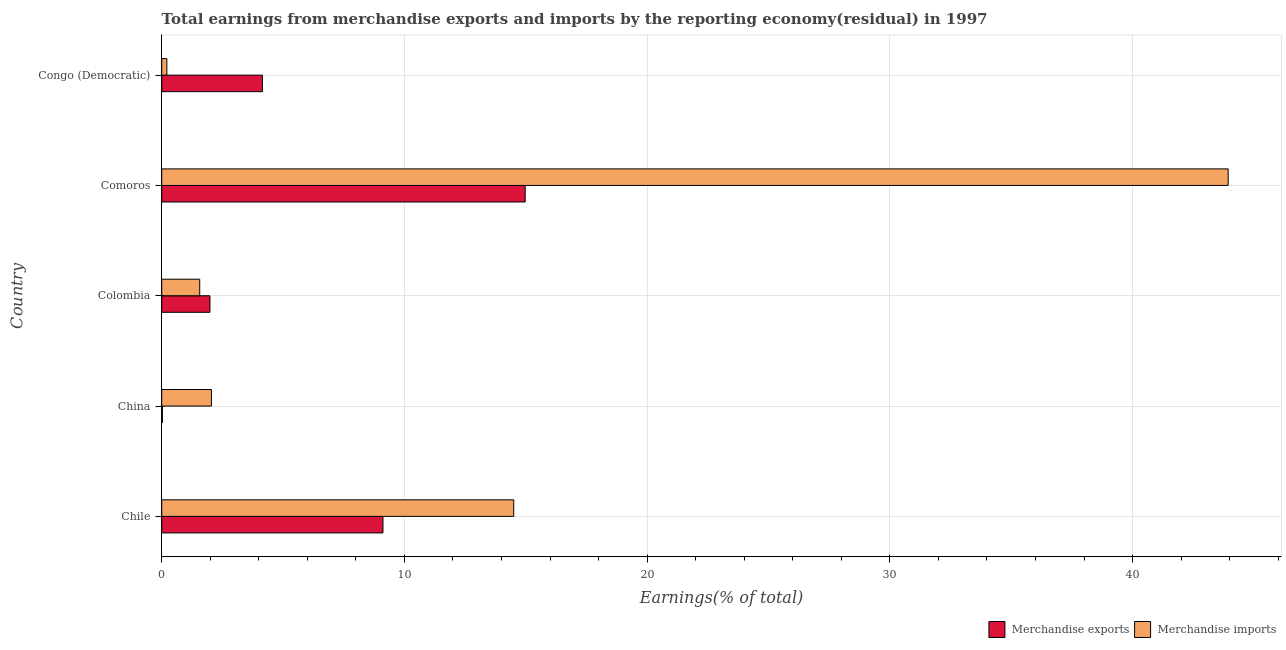How many groups of bars are there?
Your answer should be compact. 5. Are the number of bars per tick equal to the number of legend labels?
Provide a succinct answer. Yes. Are the number of bars on each tick of the Y-axis equal?
Your answer should be compact. Yes. How many bars are there on the 1st tick from the top?
Offer a terse response. 2. What is the earnings from merchandise imports in Chile?
Ensure brevity in your answer.  14.5. Across all countries, what is the maximum earnings from merchandise imports?
Your answer should be very brief. 43.94. Across all countries, what is the minimum earnings from merchandise exports?
Provide a short and direct response. 0.03. In which country was the earnings from merchandise imports maximum?
Make the answer very short. Comoros. What is the total earnings from merchandise exports in the graph?
Your answer should be compact. 30.26. What is the difference between the earnings from merchandise imports in China and that in Comoros?
Keep it short and to the point. -41.89. What is the difference between the earnings from merchandise exports in Colombia and the earnings from merchandise imports in Chile?
Offer a very short reply. -12.52. What is the average earnings from merchandise imports per country?
Give a very brief answer. 12.45. What is the difference between the earnings from merchandise imports and earnings from merchandise exports in Chile?
Offer a very short reply. 5.39. What is the ratio of the earnings from merchandise imports in Comoros to that in Congo (Democratic)?
Your response must be concise. 207.36. Is the earnings from merchandise imports in China less than that in Colombia?
Your answer should be very brief. No. Is the difference between the earnings from merchandise exports in China and Comoros greater than the difference between the earnings from merchandise imports in China and Comoros?
Provide a short and direct response. Yes. What is the difference between the highest and the second highest earnings from merchandise exports?
Provide a succinct answer. 5.86. What is the difference between the highest and the lowest earnings from merchandise imports?
Give a very brief answer. 43.73. In how many countries, is the earnings from merchandise imports greater than the average earnings from merchandise imports taken over all countries?
Offer a terse response. 2. Is the sum of the earnings from merchandise imports in Chile and Comoros greater than the maximum earnings from merchandise exports across all countries?
Provide a short and direct response. Yes. What does the 2nd bar from the top in China represents?
Keep it short and to the point. Merchandise exports. What does the 1st bar from the bottom in Colombia represents?
Offer a terse response. Merchandise exports. Are all the bars in the graph horizontal?
Your response must be concise. Yes. How many countries are there in the graph?
Give a very brief answer. 5. Does the graph contain any zero values?
Make the answer very short. No. Where does the legend appear in the graph?
Offer a very short reply. Bottom right. How many legend labels are there?
Make the answer very short. 2. How are the legend labels stacked?
Keep it short and to the point. Horizontal. What is the title of the graph?
Your answer should be very brief. Total earnings from merchandise exports and imports by the reporting economy(residual) in 1997. Does "Registered firms" appear as one of the legend labels in the graph?
Make the answer very short. No. What is the label or title of the X-axis?
Keep it short and to the point. Earnings(% of total). What is the label or title of the Y-axis?
Provide a succinct answer. Country. What is the Earnings(% of total) in Merchandise exports in Chile?
Offer a terse response. 9.12. What is the Earnings(% of total) in Merchandise imports in Chile?
Offer a very short reply. 14.5. What is the Earnings(% of total) in Merchandise exports in China?
Your response must be concise. 0.03. What is the Earnings(% of total) in Merchandise imports in China?
Offer a terse response. 2.05. What is the Earnings(% of total) of Merchandise exports in Colombia?
Your response must be concise. 1.99. What is the Earnings(% of total) in Merchandise imports in Colombia?
Offer a terse response. 1.57. What is the Earnings(% of total) of Merchandise exports in Comoros?
Make the answer very short. 14.98. What is the Earnings(% of total) in Merchandise imports in Comoros?
Ensure brevity in your answer.  43.94. What is the Earnings(% of total) in Merchandise exports in Congo (Democratic)?
Provide a succinct answer. 4.15. What is the Earnings(% of total) in Merchandise imports in Congo (Democratic)?
Offer a terse response. 0.21. Across all countries, what is the maximum Earnings(% of total) of Merchandise exports?
Give a very brief answer. 14.98. Across all countries, what is the maximum Earnings(% of total) in Merchandise imports?
Offer a very short reply. 43.94. Across all countries, what is the minimum Earnings(% of total) of Merchandise exports?
Ensure brevity in your answer.  0.03. Across all countries, what is the minimum Earnings(% of total) in Merchandise imports?
Offer a very short reply. 0.21. What is the total Earnings(% of total) in Merchandise exports in the graph?
Give a very brief answer. 30.26. What is the total Earnings(% of total) of Merchandise imports in the graph?
Give a very brief answer. 62.27. What is the difference between the Earnings(% of total) in Merchandise exports in Chile and that in China?
Offer a terse response. 9.09. What is the difference between the Earnings(% of total) of Merchandise imports in Chile and that in China?
Your response must be concise. 12.46. What is the difference between the Earnings(% of total) of Merchandise exports in Chile and that in Colombia?
Offer a very short reply. 7.13. What is the difference between the Earnings(% of total) of Merchandise imports in Chile and that in Colombia?
Your answer should be very brief. 12.94. What is the difference between the Earnings(% of total) of Merchandise exports in Chile and that in Comoros?
Your response must be concise. -5.86. What is the difference between the Earnings(% of total) in Merchandise imports in Chile and that in Comoros?
Provide a short and direct response. -29.44. What is the difference between the Earnings(% of total) of Merchandise exports in Chile and that in Congo (Democratic)?
Offer a very short reply. 4.97. What is the difference between the Earnings(% of total) in Merchandise imports in Chile and that in Congo (Democratic)?
Provide a succinct answer. 14.29. What is the difference between the Earnings(% of total) of Merchandise exports in China and that in Colombia?
Give a very brief answer. -1.96. What is the difference between the Earnings(% of total) in Merchandise imports in China and that in Colombia?
Make the answer very short. 0.48. What is the difference between the Earnings(% of total) of Merchandise exports in China and that in Comoros?
Make the answer very short. -14.95. What is the difference between the Earnings(% of total) in Merchandise imports in China and that in Comoros?
Keep it short and to the point. -41.89. What is the difference between the Earnings(% of total) of Merchandise exports in China and that in Congo (Democratic)?
Offer a very short reply. -4.12. What is the difference between the Earnings(% of total) in Merchandise imports in China and that in Congo (Democratic)?
Provide a short and direct response. 1.84. What is the difference between the Earnings(% of total) in Merchandise exports in Colombia and that in Comoros?
Your answer should be very brief. -12.99. What is the difference between the Earnings(% of total) in Merchandise imports in Colombia and that in Comoros?
Make the answer very short. -42.37. What is the difference between the Earnings(% of total) in Merchandise exports in Colombia and that in Congo (Democratic)?
Give a very brief answer. -2.16. What is the difference between the Earnings(% of total) of Merchandise imports in Colombia and that in Congo (Democratic)?
Offer a terse response. 1.35. What is the difference between the Earnings(% of total) of Merchandise exports in Comoros and that in Congo (Democratic)?
Provide a succinct answer. 10.83. What is the difference between the Earnings(% of total) of Merchandise imports in Comoros and that in Congo (Democratic)?
Keep it short and to the point. 43.73. What is the difference between the Earnings(% of total) of Merchandise exports in Chile and the Earnings(% of total) of Merchandise imports in China?
Ensure brevity in your answer.  7.07. What is the difference between the Earnings(% of total) in Merchandise exports in Chile and the Earnings(% of total) in Merchandise imports in Colombia?
Provide a succinct answer. 7.55. What is the difference between the Earnings(% of total) of Merchandise exports in Chile and the Earnings(% of total) of Merchandise imports in Comoros?
Your response must be concise. -34.82. What is the difference between the Earnings(% of total) in Merchandise exports in Chile and the Earnings(% of total) in Merchandise imports in Congo (Democratic)?
Provide a short and direct response. 8.9. What is the difference between the Earnings(% of total) of Merchandise exports in China and the Earnings(% of total) of Merchandise imports in Colombia?
Ensure brevity in your answer.  -1.54. What is the difference between the Earnings(% of total) in Merchandise exports in China and the Earnings(% of total) in Merchandise imports in Comoros?
Offer a very short reply. -43.91. What is the difference between the Earnings(% of total) in Merchandise exports in China and the Earnings(% of total) in Merchandise imports in Congo (Democratic)?
Your answer should be very brief. -0.18. What is the difference between the Earnings(% of total) in Merchandise exports in Colombia and the Earnings(% of total) in Merchandise imports in Comoros?
Make the answer very short. -41.95. What is the difference between the Earnings(% of total) in Merchandise exports in Colombia and the Earnings(% of total) in Merchandise imports in Congo (Democratic)?
Ensure brevity in your answer.  1.78. What is the difference between the Earnings(% of total) in Merchandise exports in Comoros and the Earnings(% of total) in Merchandise imports in Congo (Democratic)?
Your answer should be compact. 14.76. What is the average Earnings(% of total) of Merchandise exports per country?
Offer a terse response. 6.05. What is the average Earnings(% of total) in Merchandise imports per country?
Offer a terse response. 12.45. What is the difference between the Earnings(% of total) in Merchandise exports and Earnings(% of total) in Merchandise imports in Chile?
Offer a terse response. -5.39. What is the difference between the Earnings(% of total) of Merchandise exports and Earnings(% of total) of Merchandise imports in China?
Provide a succinct answer. -2.02. What is the difference between the Earnings(% of total) in Merchandise exports and Earnings(% of total) in Merchandise imports in Colombia?
Offer a terse response. 0.42. What is the difference between the Earnings(% of total) of Merchandise exports and Earnings(% of total) of Merchandise imports in Comoros?
Give a very brief answer. -28.96. What is the difference between the Earnings(% of total) in Merchandise exports and Earnings(% of total) in Merchandise imports in Congo (Democratic)?
Provide a short and direct response. 3.94. What is the ratio of the Earnings(% of total) of Merchandise exports in Chile to that in China?
Give a very brief answer. 336.34. What is the ratio of the Earnings(% of total) of Merchandise imports in Chile to that in China?
Your answer should be very brief. 7.08. What is the ratio of the Earnings(% of total) of Merchandise exports in Chile to that in Colombia?
Offer a very short reply. 4.59. What is the ratio of the Earnings(% of total) of Merchandise imports in Chile to that in Colombia?
Your response must be concise. 9.26. What is the ratio of the Earnings(% of total) of Merchandise exports in Chile to that in Comoros?
Keep it short and to the point. 0.61. What is the ratio of the Earnings(% of total) of Merchandise imports in Chile to that in Comoros?
Ensure brevity in your answer.  0.33. What is the ratio of the Earnings(% of total) in Merchandise exports in Chile to that in Congo (Democratic)?
Offer a very short reply. 2.2. What is the ratio of the Earnings(% of total) of Merchandise imports in Chile to that in Congo (Democratic)?
Give a very brief answer. 68.45. What is the ratio of the Earnings(% of total) of Merchandise exports in China to that in Colombia?
Offer a very short reply. 0.01. What is the ratio of the Earnings(% of total) in Merchandise imports in China to that in Colombia?
Offer a terse response. 1.31. What is the ratio of the Earnings(% of total) of Merchandise exports in China to that in Comoros?
Give a very brief answer. 0. What is the ratio of the Earnings(% of total) in Merchandise imports in China to that in Comoros?
Keep it short and to the point. 0.05. What is the ratio of the Earnings(% of total) of Merchandise exports in China to that in Congo (Democratic)?
Your answer should be compact. 0.01. What is the ratio of the Earnings(% of total) in Merchandise imports in China to that in Congo (Democratic)?
Ensure brevity in your answer.  9.67. What is the ratio of the Earnings(% of total) of Merchandise exports in Colombia to that in Comoros?
Provide a succinct answer. 0.13. What is the ratio of the Earnings(% of total) in Merchandise imports in Colombia to that in Comoros?
Keep it short and to the point. 0.04. What is the ratio of the Earnings(% of total) in Merchandise exports in Colombia to that in Congo (Democratic)?
Your answer should be compact. 0.48. What is the ratio of the Earnings(% of total) of Merchandise imports in Colombia to that in Congo (Democratic)?
Ensure brevity in your answer.  7.39. What is the ratio of the Earnings(% of total) of Merchandise exports in Comoros to that in Congo (Democratic)?
Provide a short and direct response. 3.61. What is the ratio of the Earnings(% of total) of Merchandise imports in Comoros to that in Congo (Democratic)?
Ensure brevity in your answer.  207.36. What is the difference between the highest and the second highest Earnings(% of total) in Merchandise exports?
Your answer should be compact. 5.86. What is the difference between the highest and the second highest Earnings(% of total) in Merchandise imports?
Ensure brevity in your answer.  29.44. What is the difference between the highest and the lowest Earnings(% of total) in Merchandise exports?
Offer a very short reply. 14.95. What is the difference between the highest and the lowest Earnings(% of total) in Merchandise imports?
Provide a short and direct response. 43.73. 